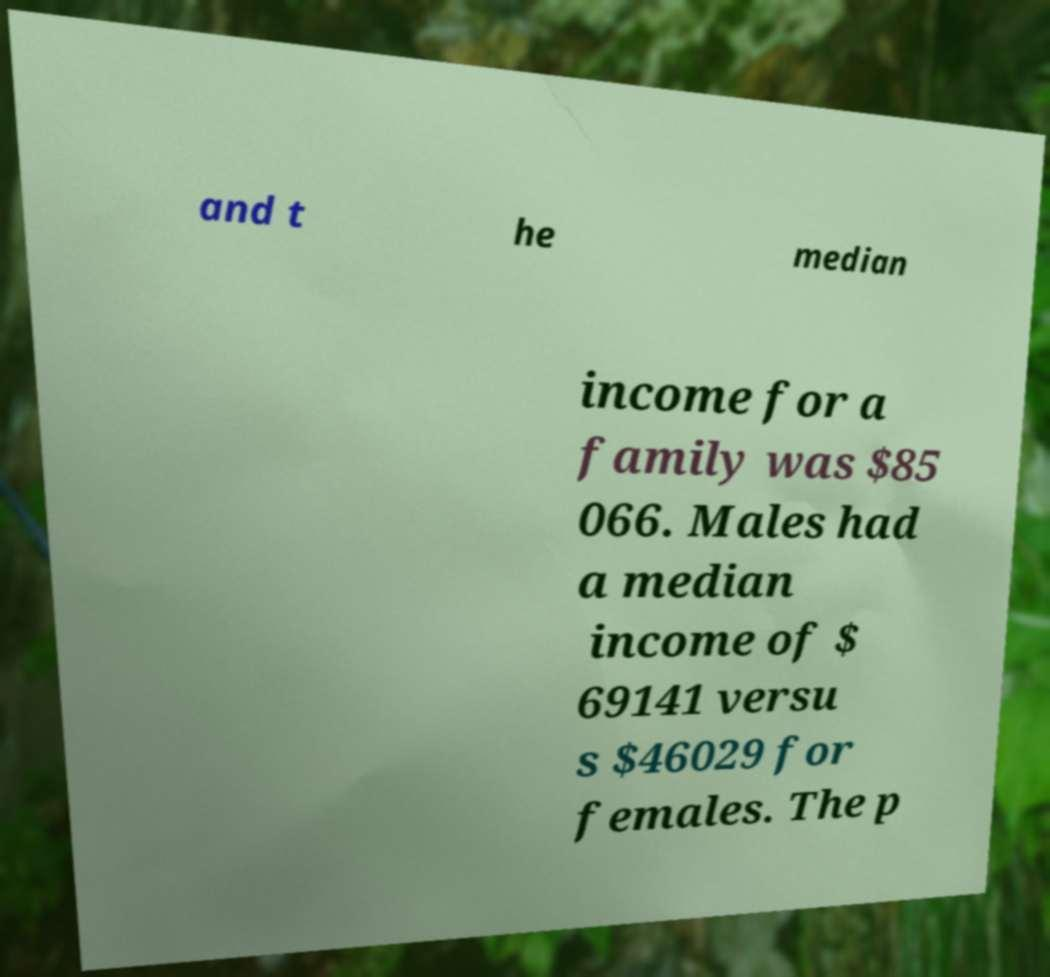I need the written content from this picture converted into text. Can you do that? and t he median income for a family was $85 066. Males had a median income of $ 69141 versu s $46029 for females. The p 